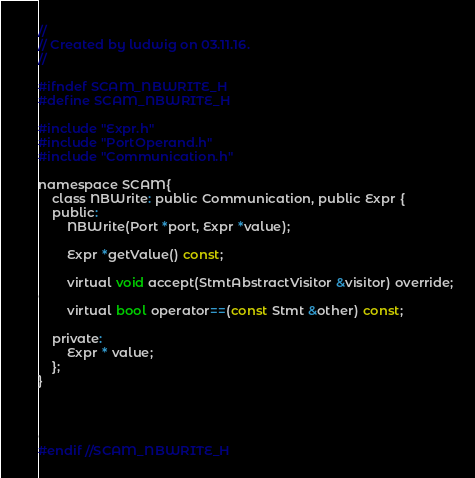<code> <loc_0><loc_0><loc_500><loc_500><_C_>//
// Created by ludwig on 03.11.16.
//

#ifndef SCAM_NBWRITE_H
#define SCAM_NBWRITE_H

#include "Expr.h"
#include "PortOperand.h"
#include "Communication.h"

namespace SCAM{
    class NBWrite: public Communication, public Expr {
    public:
        NBWrite(Port *port, Expr *value);

        Expr *getValue() const;

        virtual void accept(StmtAbstractVisitor &visitor) override;

        virtual bool operator==(const Stmt &other) const;

    private:
        Expr * value;
    };
}




#endif //SCAM_NBWRITE_H
</code> 